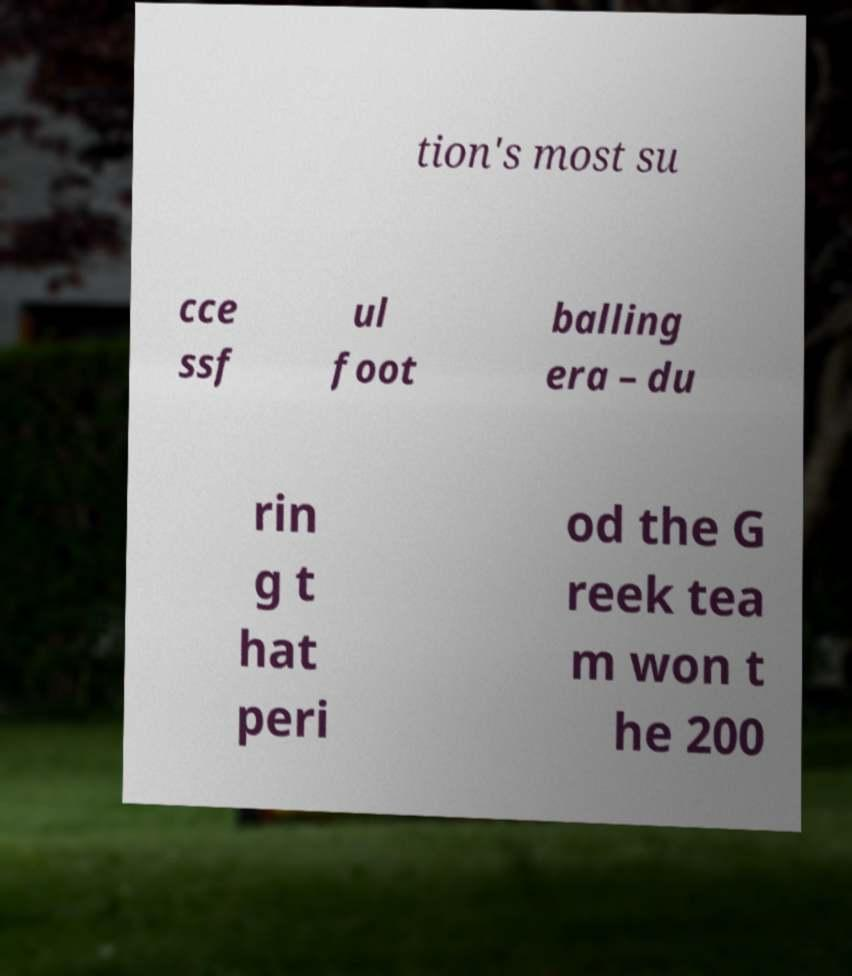What messages or text are displayed in this image? I need them in a readable, typed format. tion's most su cce ssf ul foot balling era – du rin g t hat peri od the G reek tea m won t he 200 